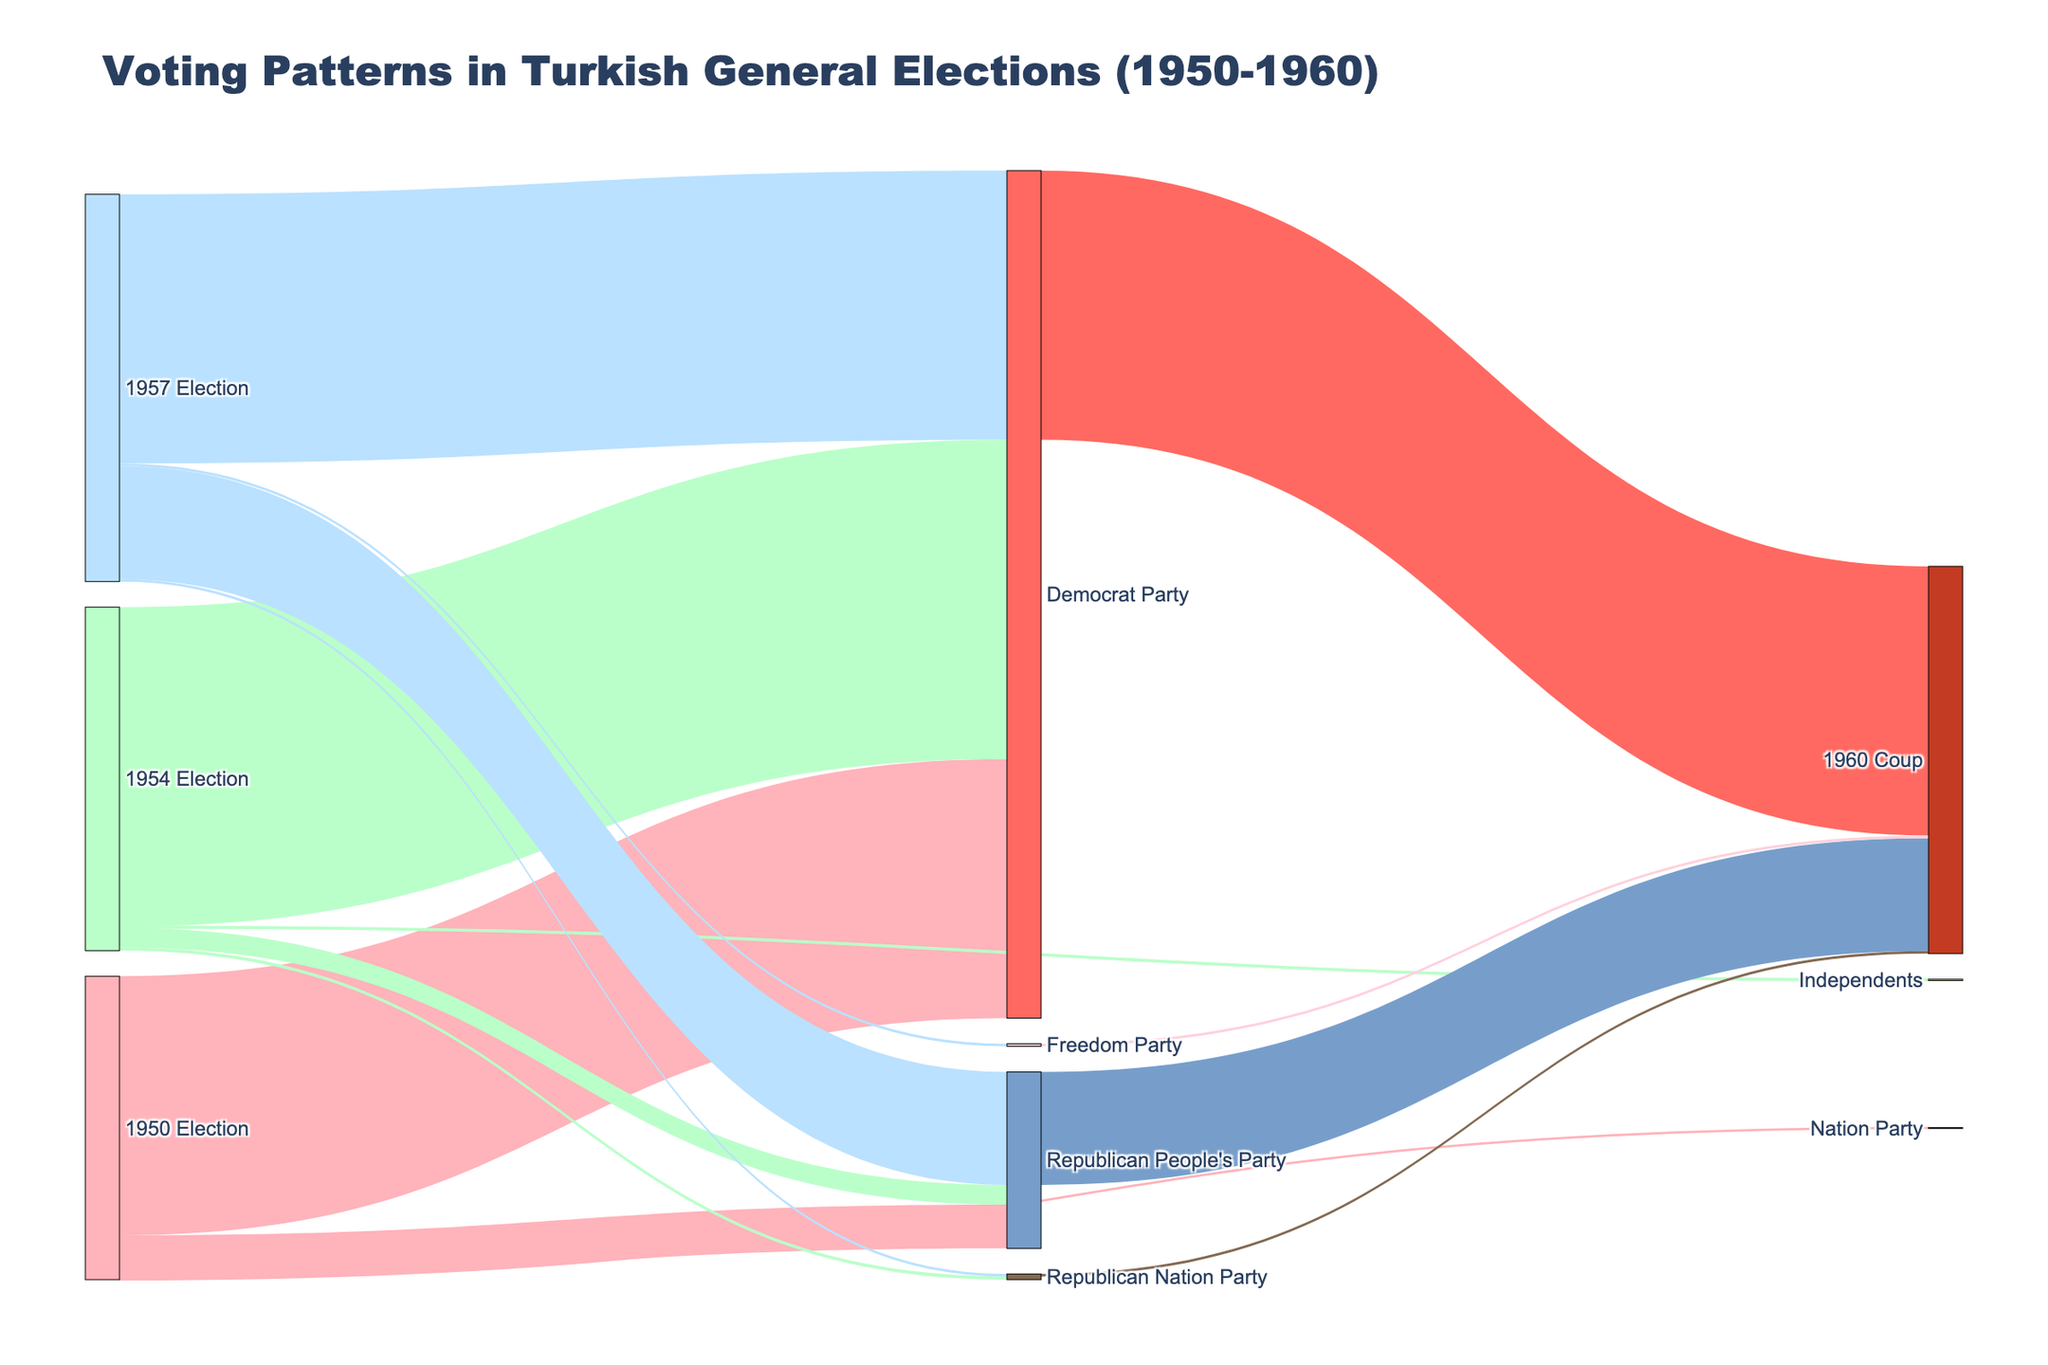Which party received the most votes in the 1950 election? From the Sankey Diagram, we can see the length of the link representing votes. The Democrat Party received the longest link from the 1950 Election.
Answer: Democrat Party How many parties participated in the 1957 election? The Sankey Diagram shows four different links coming from the 1957 Election node to their respective parties.
Answer: Four What was the trend in Democrat Party's votes from 1950 to 1954? The link from the Democrat Party shows a lengthening from the 1950 Election (408 votes) to the 1954 Election (503 votes).
Answer: Increased What happened to the parties' votes after the 1960 coup? The Sankey Diagram indicates that all votes from the Democrat Party, Republican People's Party, Republican Nation Party, and Freedom Party are directed to the 1960 Coup.
Answer: All votes to 1960 Coup Which party had a significant increase in votes in the 1957 election compared to the 1954 election? By comparing the lengths of the links, the Republican People's Party had a significant increase from 31 votes in 1954 to 178 votes in 1957.
Answer: Republican People's Party What's the overall trend of the Republican People's Party votes from 1950 to 1960? The Sankey Diagram shows a decrease from 69 votes in the 1950 Election to 31 votes in the 1954 Election, then an increase to 178 votes in the 1957 Election. Finally, their votes go to the 1960 Coup.
Answer: Fluctuated How many total independents received votes in 1954? From the Sankey Diagram, we see a link from the 1954 Election to Independents with 2 votes.
Answer: 2 Which party had the least votes in the 1957 election and how many? The Sankey Diagram indicates that both the Republican Nation Party and the Freedom Party had 4 votes, making them the parties with the least votes in 1957.
Answer: Republican Nation Party and Freedom Party, 4 votes Compare the sum of all votes in the 1954 and 1957 elections. Which year had more votes? Adding the votes from the links: 1954 Election (Democrat Party: 503, Republican People’s Party: 31, Republican Nation Party: 5, Independents: 2) sums to 541, and 1957 Election (Democrat Party: 424, Republican People’s Party: 178, Republican Nation Party: 4, Freedom Party: 4) sums to 610.
Answer: 1957 Election What was the fate of the Freedom Party's votes in 1960? The Sankey Diagram shows a link going from the Freedom Party to the 1960 Coup, indicating their votes were directed towards the 1960 Coup.
Answer: Directed to the 1960 Coup 